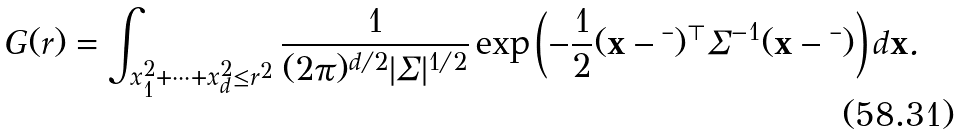Convert formula to latex. <formula><loc_0><loc_0><loc_500><loc_500>G ( r ) = \int _ { x _ { 1 } ^ { 2 } + \cdots + x _ { d } ^ { 2 } \leq r ^ { 2 } } \frac { 1 } { ( 2 \pi ) ^ { d / 2 } | \Sigma | ^ { 1 / 2 } } \exp \left ( - \frac { 1 } { 2 } ( \mathbf x - \mathbf \mu ) ^ { \top } \Sigma ^ { - 1 } ( \mathbf x - \mathbf \mu ) \right ) d \mathbf x .</formula> 